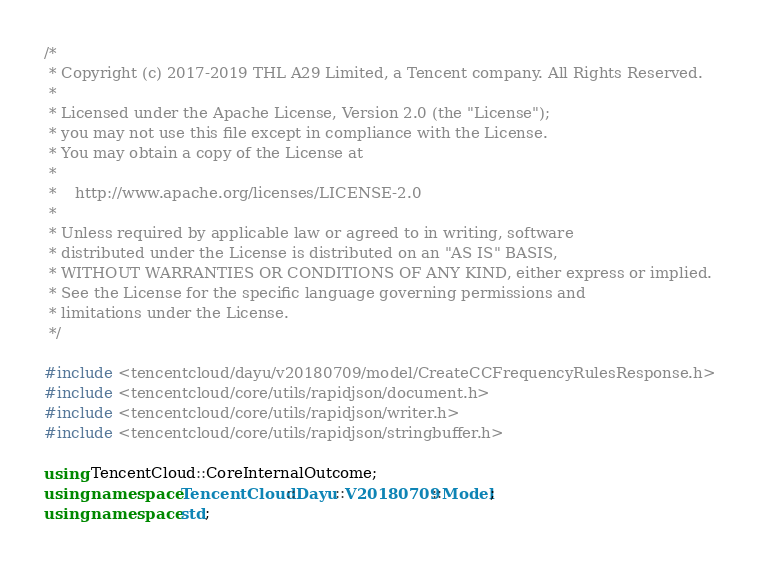<code> <loc_0><loc_0><loc_500><loc_500><_C++_>/*
 * Copyright (c) 2017-2019 THL A29 Limited, a Tencent company. All Rights Reserved.
 *
 * Licensed under the Apache License, Version 2.0 (the "License");
 * you may not use this file except in compliance with the License.
 * You may obtain a copy of the License at
 *
 *    http://www.apache.org/licenses/LICENSE-2.0
 *
 * Unless required by applicable law or agreed to in writing, software
 * distributed under the License is distributed on an "AS IS" BASIS,
 * WITHOUT WARRANTIES OR CONDITIONS OF ANY KIND, either express or implied.
 * See the License for the specific language governing permissions and
 * limitations under the License.
 */

#include <tencentcloud/dayu/v20180709/model/CreateCCFrequencyRulesResponse.h>
#include <tencentcloud/core/utils/rapidjson/document.h>
#include <tencentcloud/core/utils/rapidjson/writer.h>
#include <tencentcloud/core/utils/rapidjson/stringbuffer.h>

using TencentCloud::CoreInternalOutcome;
using namespace TencentCloud::Dayu::V20180709::Model;
using namespace std;
</code> 